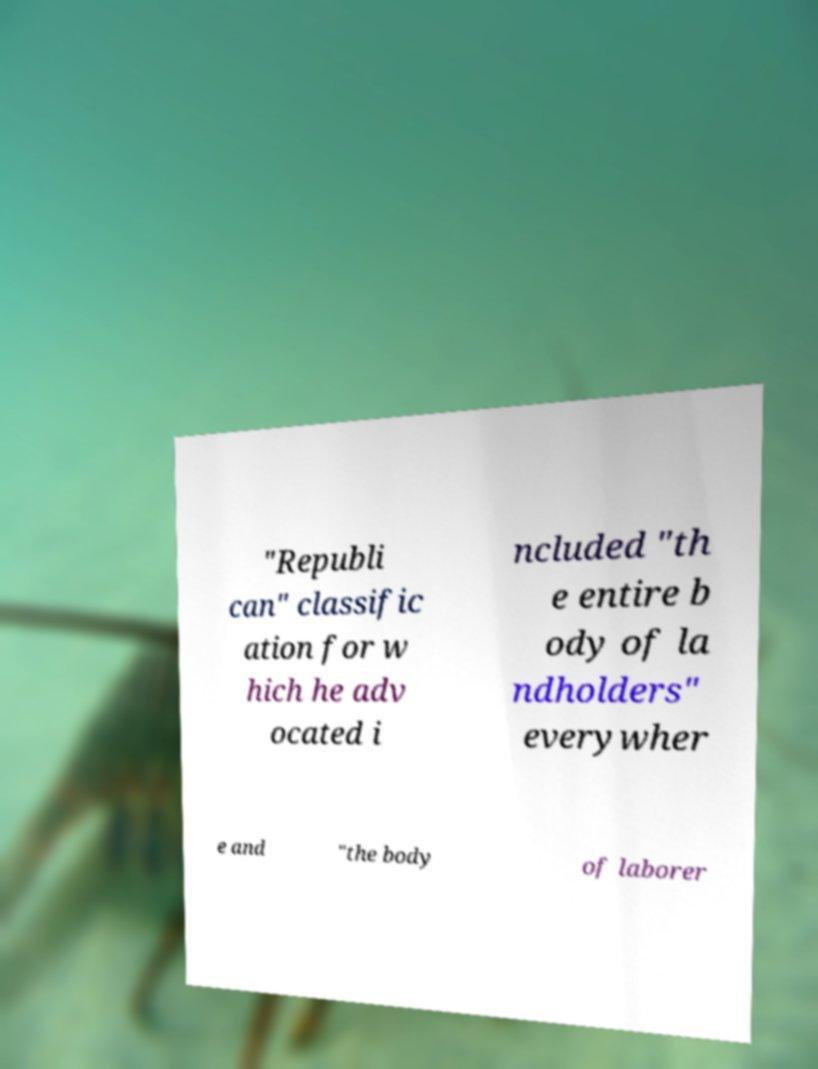There's text embedded in this image that I need extracted. Can you transcribe it verbatim? "Republi can" classific ation for w hich he adv ocated i ncluded "th e entire b ody of la ndholders" everywher e and "the body of laborer 